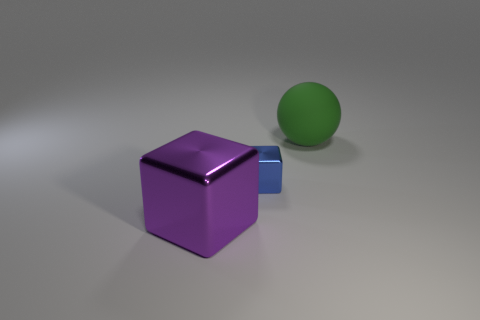Add 2 large green spheres. How many objects exist? 5 Subtract all cubes. How many objects are left? 1 Subtract 0 brown cubes. How many objects are left? 3 Subtract all rubber balls. Subtract all big yellow matte spheres. How many objects are left? 2 Add 1 large purple things. How many large purple things are left? 2 Add 1 shiny objects. How many shiny objects exist? 3 